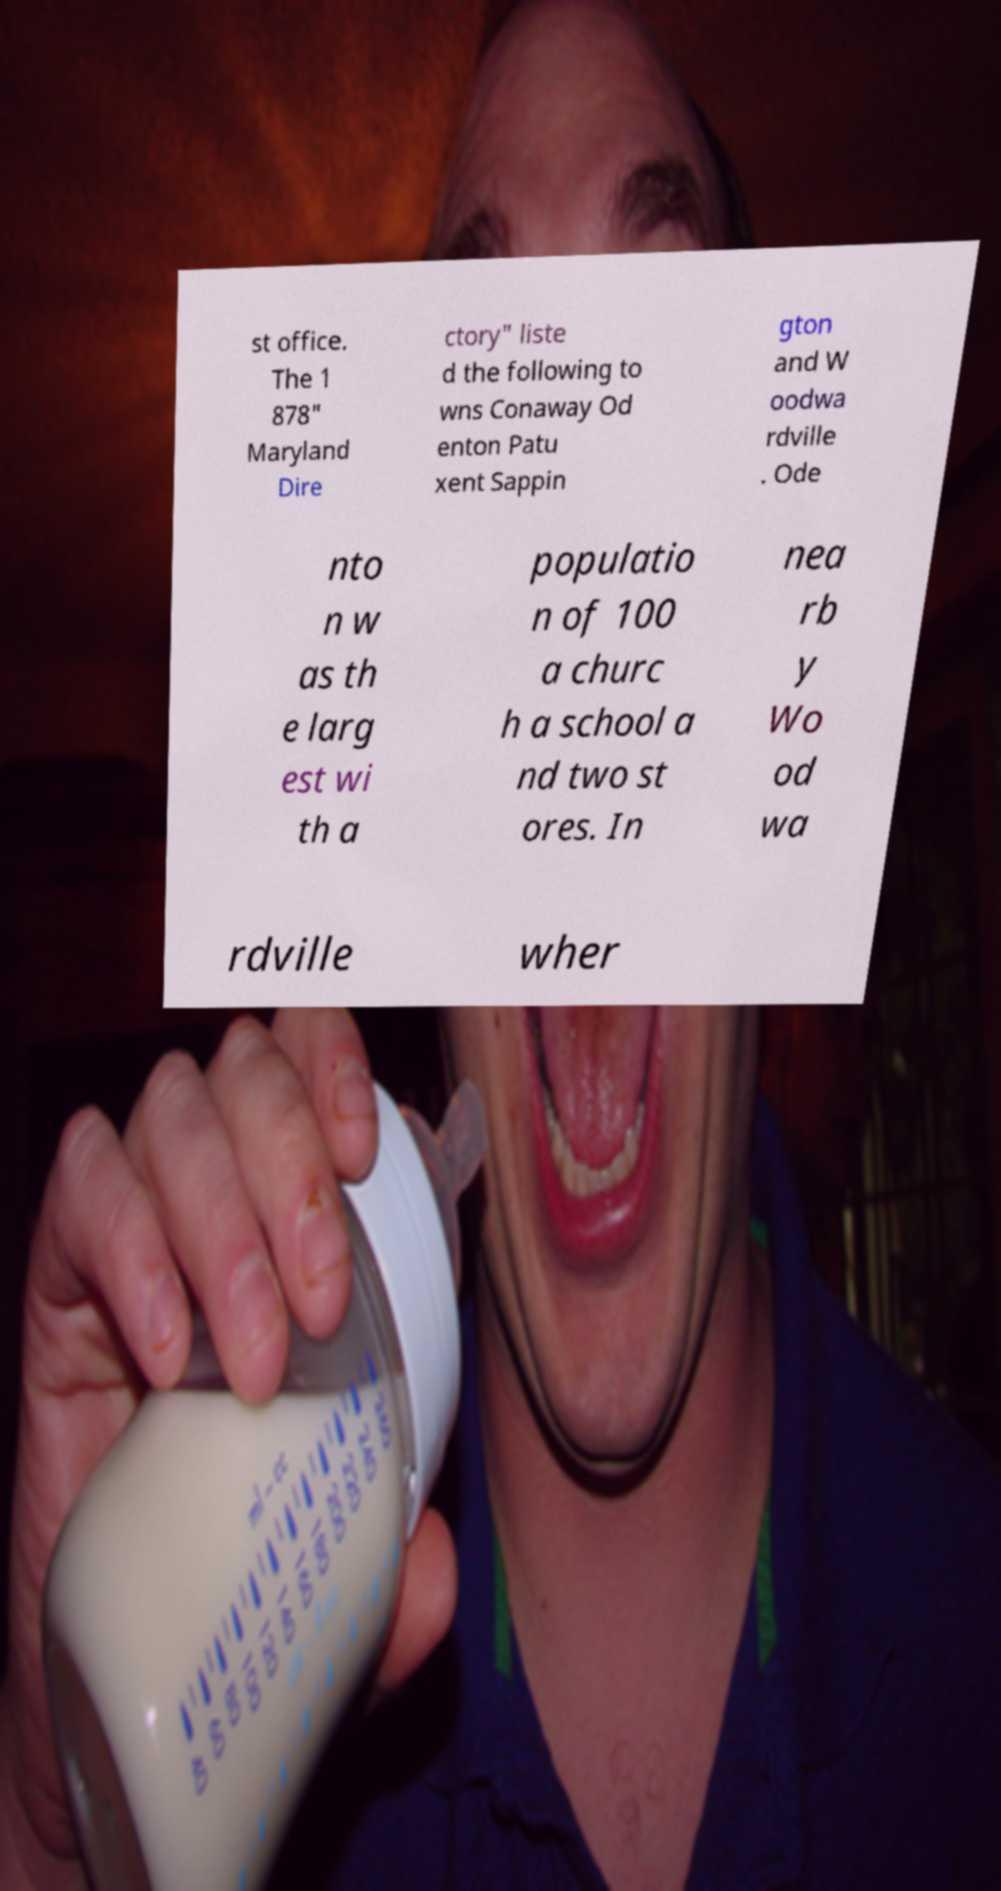Please read and relay the text visible in this image. What does it say? st office. The 1 878" Maryland Dire ctory" liste d the following to wns Conaway Od enton Patu xent Sappin gton and W oodwa rdville . Ode nto n w as th e larg est wi th a populatio n of 100 a churc h a school a nd two st ores. In nea rb y Wo od wa rdville wher 